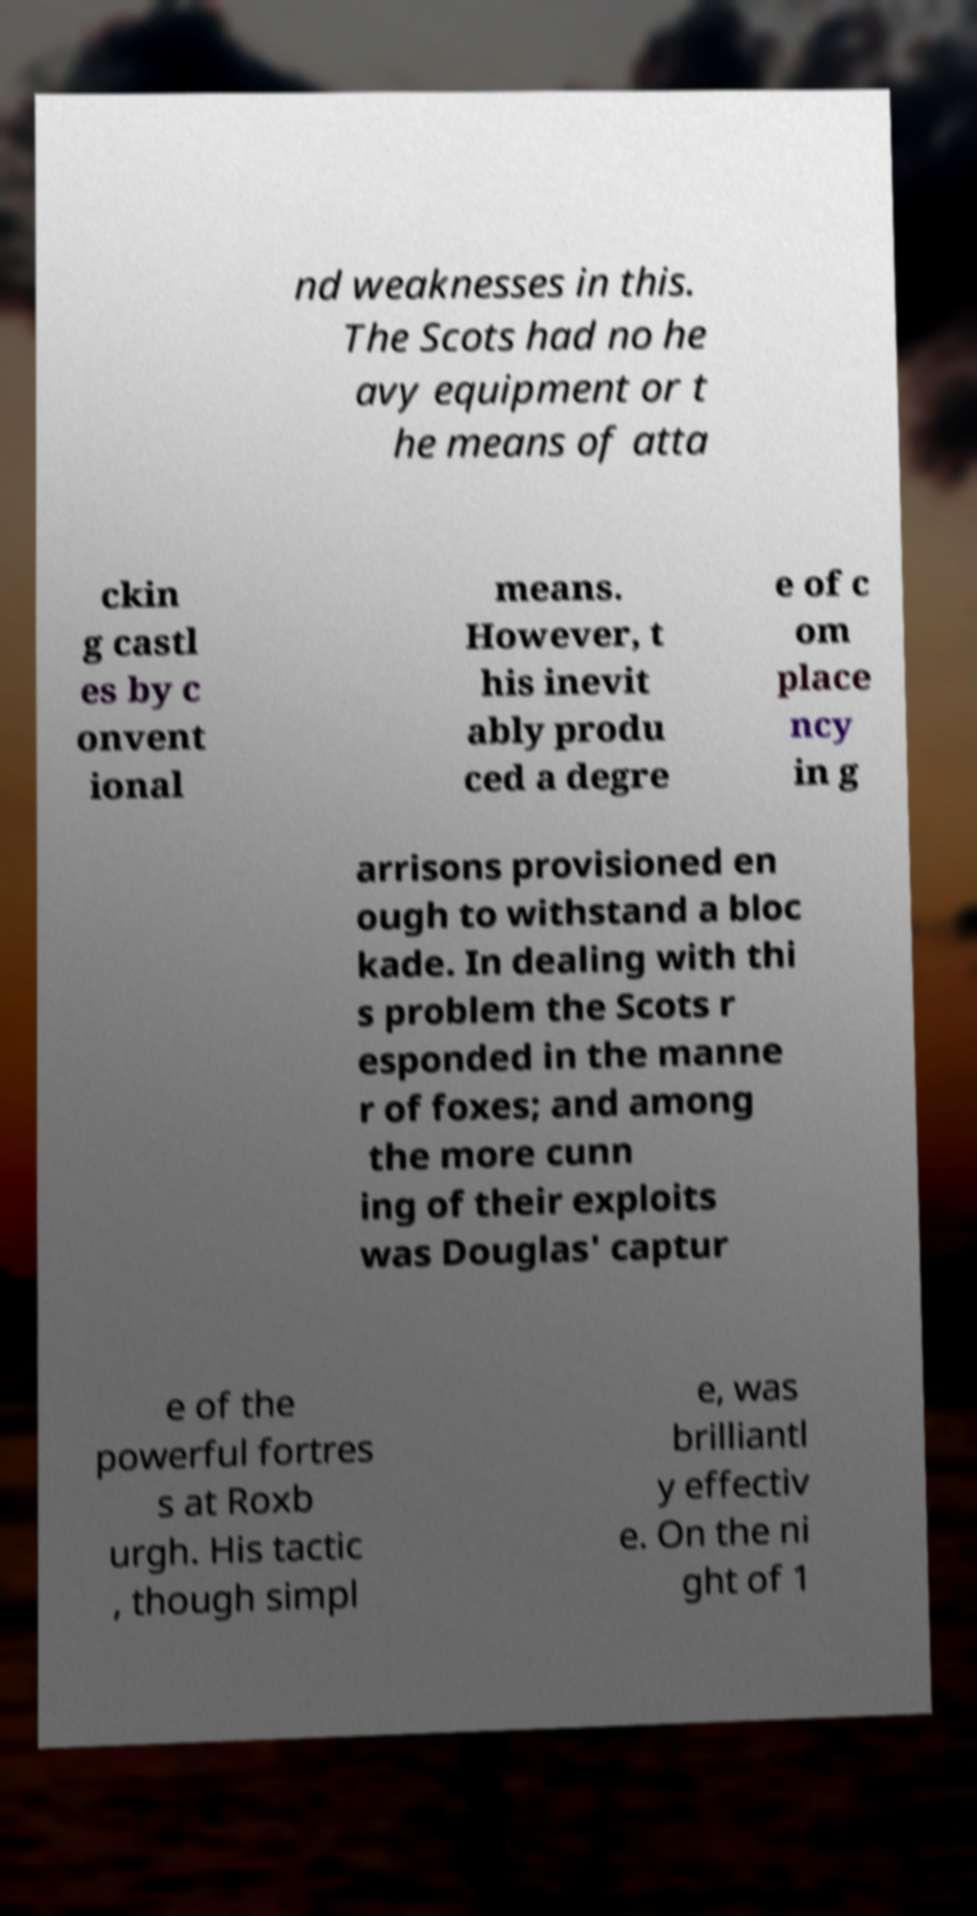Please read and relay the text visible in this image. What does it say? nd weaknesses in this. The Scots had no he avy equipment or t he means of atta ckin g castl es by c onvent ional means. However, t his inevit ably produ ced a degre e of c om place ncy in g arrisons provisioned en ough to withstand a bloc kade. In dealing with thi s problem the Scots r esponded in the manne r of foxes; and among the more cunn ing of their exploits was Douglas' captur e of the powerful fortres s at Roxb urgh. His tactic , though simpl e, was brilliantl y effectiv e. On the ni ght of 1 